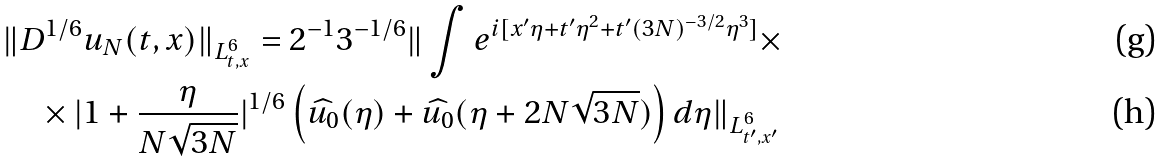Convert formula to latex. <formula><loc_0><loc_0><loc_500><loc_500>& \| D ^ { 1 / 6 } u _ { N } ( t , x ) \| _ { L ^ { 6 } _ { t , x } } = 2 ^ { - 1 } 3 ^ { - 1 / 6 } \| \int e ^ { i [ x ^ { \prime } \eta + t ^ { \prime } \eta ^ { 2 } + t ^ { \prime } ( 3 N ) ^ { - 3 / 2 } \eta ^ { 3 } ] } \times \\ & \quad \times | 1 + \frac { \eta } { N \sqrt { 3 N } } | ^ { 1 / 6 } \left ( \widehat { u _ { 0 } } ( \eta ) + \widehat { u _ { 0 } } ( \eta + 2 N \sqrt { 3 N } ) \right ) d \eta \| _ { L ^ { 6 } _ { t ^ { \prime } , x ^ { \prime } } }</formula> 